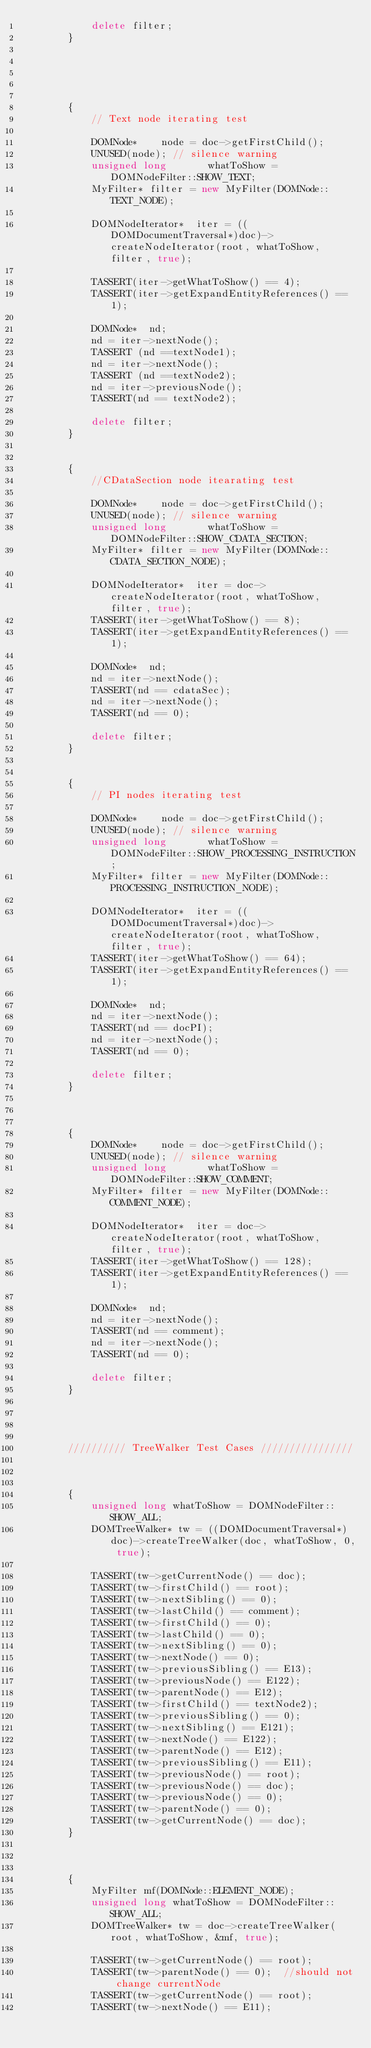<code> <loc_0><loc_0><loc_500><loc_500><_C++_>            delete filter;
        }





        {
            // Text node iterating test

            DOMNode*    node = doc->getFirstChild();
            UNUSED(node); // silence warning
            unsigned long       whatToShow = DOMNodeFilter::SHOW_TEXT;
            MyFilter* filter = new MyFilter(DOMNode::TEXT_NODE);

            DOMNodeIterator*  iter = ((DOMDocumentTraversal*)doc)->createNodeIterator(root, whatToShow,  filter, true);

            TASSERT(iter->getWhatToShow() == 4);
            TASSERT(iter->getExpandEntityReferences() == 1);

            DOMNode*  nd;
            nd = iter->nextNode();
            TASSERT (nd ==textNode1);
            nd = iter->nextNode();
            TASSERT (nd ==textNode2);
            nd = iter->previousNode();
            TASSERT(nd == textNode2);

            delete filter;
        }


        {
            //CDataSection node itearating test

            DOMNode*    node = doc->getFirstChild();
            UNUSED(node); // silence warning
            unsigned long       whatToShow = DOMNodeFilter::SHOW_CDATA_SECTION;
            MyFilter* filter = new MyFilter(DOMNode::CDATA_SECTION_NODE);

            DOMNodeIterator*  iter = doc->createNodeIterator(root, whatToShow,  filter, true);
            TASSERT(iter->getWhatToShow() == 8);
            TASSERT(iter->getExpandEntityReferences() == 1);

            DOMNode*  nd;
            nd = iter->nextNode();
            TASSERT(nd == cdataSec);
            nd = iter->nextNode();
            TASSERT(nd == 0);

            delete filter;
        }


        {
            // PI nodes iterating test

            DOMNode*    node = doc->getFirstChild();
            UNUSED(node); // silence warning
            unsigned long       whatToShow = DOMNodeFilter::SHOW_PROCESSING_INSTRUCTION;
            MyFilter* filter = new MyFilter(DOMNode::PROCESSING_INSTRUCTION_NODE);

            DOMNodeIterator*  iter = ((DOMDocumentTraversal*)doc)->createNodeIterator(root, whatToShow,  filter, true);
            TASSERT(iter->getWhatToShow() == 64);
            TASSERT(iter->getExpandEntityReferences() == 1);

            DOMNode*  nd;
            nd = iter->nextNode();
            TASSERT(nd == docPI);
            nd = iter->nextNode();
            TASSERT(nd == 0);

            delete filter;
        }



        {
            DOMNode*    node = doc->getFirstChild();
            UNUSED(node); // silence warning
            unsigned long       whatToShow = DOMNodeFilter::SHOW_COMMENT;
            MyFilter* filter = new MyFilter(DOMNode::COMMENT_NODE);

            DOMNodeIterator*  iter = doc->createNodeIterator(root, whatToShow,  filter, true);
            TASSERT(iter->getWhatToShow() == 128);
            TASSERT(iter->getExpandEntityReferences() == 1);

            DOMNode*  nd;
            nd = iter->nextNode();
            TASSERT(nd == comment);
            nd = iter->nextNode();
            TASSERT(nd == 0);

            delete filter;
        }




        ////////// TreeWalker Test Cases ////////////////



        {
            unsigned long whatToShow = DOMNodeFilter::SHOW_ALL;
            DOMTreeWalker* tw = ((DOMDocumentTraversal*)doc)->createTreeWalker(doc, whatToShow, 0, true);

            TASSERT(tw->getCurrentNode() == doc);
            TASSERT(tw->firstChild() == root);
            TASSERT(tw->nextSibling() == 0);
            TASSERT(tw->lastChild() == comment);
            TASSERT(tw->firstChild() == 0);
            TASSERT(tw->lastChild() == 0);
            TASSERT(tw->nextSibling() == 0);
            TASSERT(tw->nextNode() == 0);
            TASSERT(tw->previousSibling() == E13);
            TASSERT(tw->previousNode() == E122);
            TASSERT(tw->parentNode() == E12);
            TASSERT(tw->firstChild() == textNode2);
            TASSERT(tw->previousSibling() == 0);
            TASSERT(tw->nextSibling() == E121);
            TASSERT(tw->nextNode() == E122);
            TASSERT(tw->parentNode() == E12);
            TASSERT(tw->previousSibling() == E11);
            TASSERT(tw->previousNode() == root);
            TASSERT(tw->previousNode() == doc);
            TASSERT(tw->previousNode() == 0);
            TASSERT(tw->parentNode() == 0);
            TASSERT(tw->getCurrentNode() == doc);
        }



        {
            MyFilter mf(DOMNode::ELEMENT_NODE);
            unsigned long whatToShow = DOMNodeFilter::SHOW_ALL;
            DOMTreeWalker* tw = doc->createTreeWalker(root, whatToShow, &mf, true);

            TASSERT(tw->getCurrentNode() == root);
            TASSERT(tw->parentNode() == 0);  //should not change currentNode
            TASSERT(tw->getCurrentNode() == root);
            TASSERT(tw->nextNode() == E11);</code> 